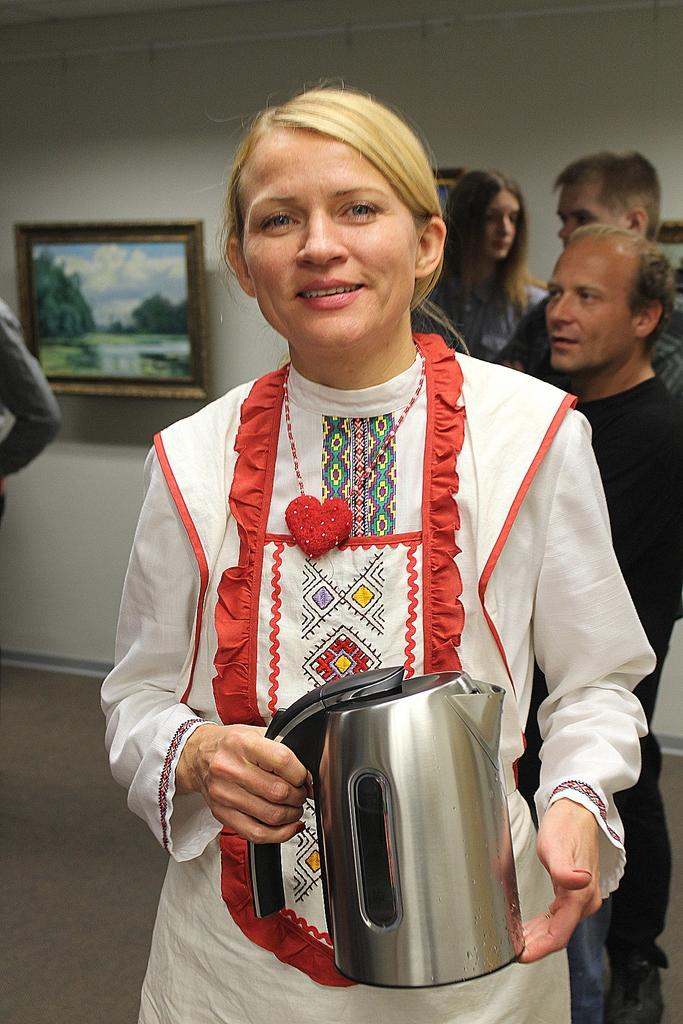What is the woman doing in the image? The woman is standing in the image. What is the woman holding in the image? The woman is holding an object. Are there any other people in the image besides the woman? Yes, there are people standing in the image. What can be seen on the wall in the background of the image? There are frames attached to the wall in the background of the image. What color are the socks worn by the bears in the image? There are no bears or socks present in the image. 